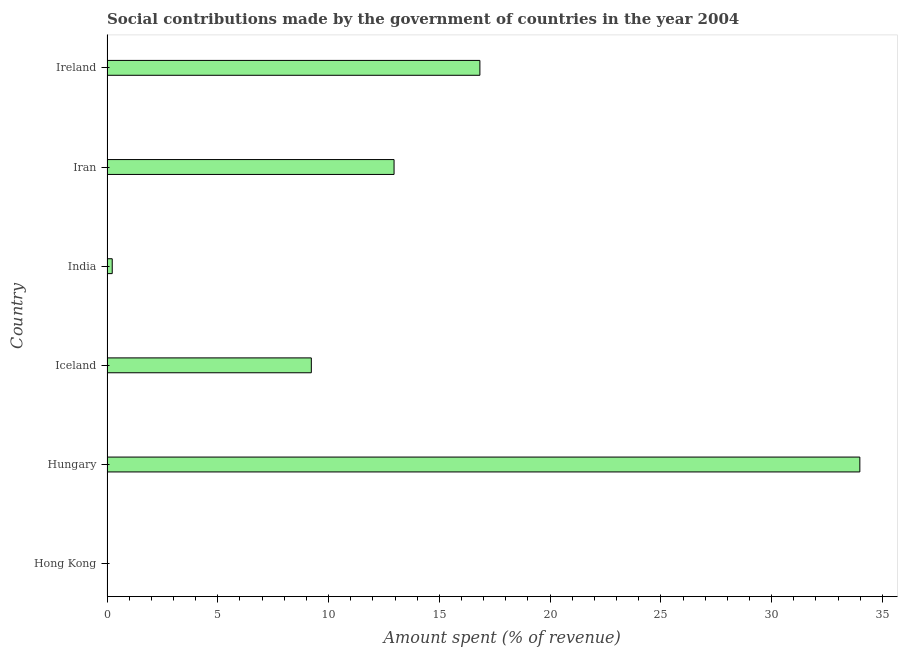Does the graph contain any zero values?
Your response must be concise. No. Does the graph contain grids?
Your answer should be very brief. No. What is the title of the graph?
Offer a terse response. Social contributions made by the government of countries in the year 2004. What is the label or title of the X-axis?
Make the answer very short. Amount spent (% of revenue). What is the amount spent in making social contributions in Hong Kong?
Ensure brevity in your answer.  0.01. Across all countries, what is the maximum amount spent in making social contributions?
Give a very brief answer. 33.98. Across all countries, what is the minimum amount spent in making social contributions?
Offer a very short reply. 0.01. In which country was the amount spent in making social contributions maximum?
Your response must be concise. Hungary. In which country was the amount spent in making social contributions minimum?
Your response must be concise. Hong Kong. What is the sum of the amount spent in making social contributions?
Offer a very short reply. 73.23. What is the difference between the amount spent in making social contributions in India and Ireland?
Ensure brevity in your answer.  -16.59. What is the average amount spent in making social contributions per country?
Give a very brief answer. 12.21. What is the median amount spent in making social contributions?
Ensure brevity in your answer.  11.09. In how many countries, is the amount spent in making social contributions greater than 4 %?
Provide a succinct answer. 4. What is the ratio of the amount spent in making social contributions in Iceland to that in India?
Your answer should be compact. 39.06. Is the amount spent in making social contributions in Hong Kong less than that in Ireland?
Ensure brevity in your answer.  Yes. Is the difference between the amount spent in making social contributions in Hong Kong and Hungary greater than the difference between any two countries?
Keep it short and to the point. Yes. What is the difference between the highest and the second highest amount spent in making social contributions?
Provide a succinct answer. 17.15. What is the difference between the highest and the lowest amount spent in making social contributions?
Offer a terse response. 33.97. Are all the bars in the graph horizontal?
Your response must be concise. Yes. Are the values on the major ticks of X-axis written in scientific E-notation?
Your answer should be very brief. No. What is the Amount spent (% of revenue) of Hong Kong?
Your answer should be compact. 0.01. What is the Amount spent (% of revenue) of Hungary?
Keep it short and to the point. 33.98. What is the Amount spent (% of revenue) in Iceland?
Make the answer very short. 9.22. What is the Amount spent (% of revenue) in India?
Keep it short and to the point. 0.24. What is the Amount spent (% of revenue) of Iran?
Ensure brevity in your answer.  12.96. What is the Amount spent (% of revenue) in Ireland?
Provide a short and direct response. 16.83. What is the difference between the Amount spent (% of revenue) in Hong Kong and Hungary?
Your answer should be compact. -33.97. What is the difference between the Amount spent (% of revenue) in Hong Kong and Iceland?
Provide a short and direct response. -9.21. What is the difference between the Amount spent (% of revenue) in Hong Kong and India?
Your answer should be very brief. -0.23. What is the difference between the Amount spent (% of revenue) in Hong Kong and Iran?
Provide a succinct answer. -12.95. What is the difference between the Amount spent (% of revenue) in Hong Kong and Ireland?
Give a very brief answer. -16.82. What is the difference between the Amount spent (% of revenue) in Hungary and Iceland?
Offer a very short reply. 24.76. What is the difference between the Amount spent (% of revenue) in Hungary and India?
Ensure brevity in your answer.  33.74. What is the difference between the Amount spent (% of revenue) in Hungary and Iran?
Offer a terse response. 21.02. What is the difference between the Amount spent (% of revenue) in Hungary and Ireland?
Offer a terse response. 17.15. What is the difference between the Amount spent (% of revenue) in Iceland and India?
Ensure brevity in your answer.  8.99. What is the difference between the Amount spent (% of revenue) in Iceland and Iran?
Make the answer very short. -3.73. What is the difference between the Amount spent (% of revenue) in Iceland and Ireland?
Offer a terse response. -7.61. What is the difference between the Amount spent (% of revenue) in India and Iran?
Give a very brief answer. -12.72. What is the difference between the Amount spent (% of revenue) in India and Ireland?
Your response must be concise. -16.59. What is the difference between the Amount spent (% of revenue) in Iran and Ireland?
Offer a very short reply. -3.87. What is the ratio of the Amount spent (% of revenue) in Hong Kong to that in India?
Offer a very short reply. 0.03. What is the ratio of the Amount spent (% of revenue) in Hungary to that in Iceland?
Ensure brevity in your answer.  3.69. What is the ratio of the Amount spent (% of revenue) in Hungary to that in India?
Make the answer very short. 143.93. What is the ratio of the Amount spent (% of revenue) in Hungary to that in Iran?
Give a very brief answer. 2.62. What is the ratio of the Amount spent (% of revenue) in Hungary to that in Ireland?
Provide a short and direct response. 2.02. What is the ratio of the Amount spent (% of revenue) in Iceland to that in India?
Provide a short and direct response. 39.06. What is the ratio of the Amount spent (% of revenue) in Iceland to that in Iran?
Provide a short and direct response. 0.71. What is the ratio of the Amount spent (% of revenue) in Iceland to that in Ireland?
Offer a terse response. 0.55. What is the ratio of the Amount spent (% of revenue) in India to that in Iran?
Provide a short and direct response. 0.02. What is the ratio of the Amount spent (% of revenue) in India to that in Ireland?
Offer a very short reply. 0.01. What is the ratio of the Amount spent (% of revenue) in Iran to that in Ireland?
Your response must be concise. 0.77. 